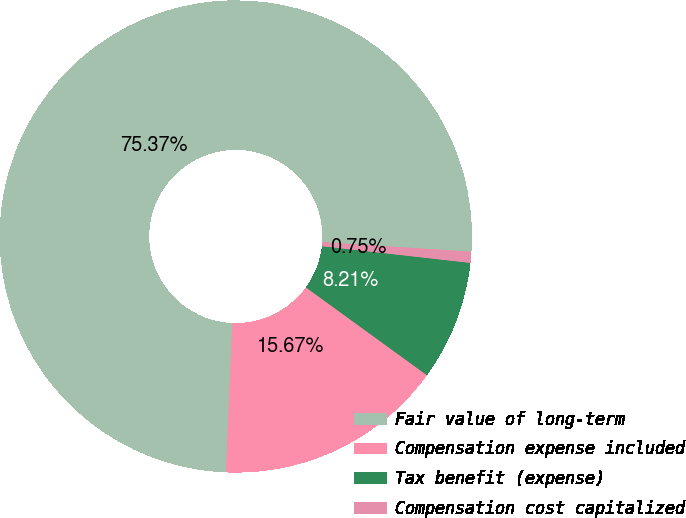Convert chart to OTSL. <chart><loc_0><loc_0><loc_500><loc_500><pie_chart><fcel>Fair value of long-term<fcel>Compensation expense included<fcel>Tax benefit (expense)<fcel>Compensation cost capitalized<nl><fcel>75.37%<fcel>15.67%<fcel>8.21%<fcel>0.75%<nl></chart> 